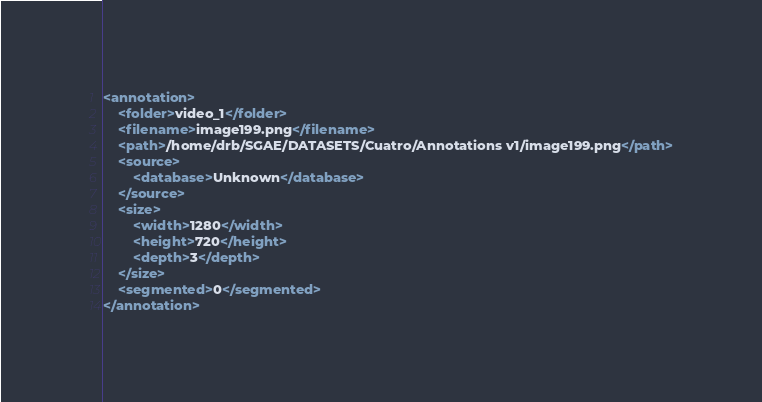<code> <loc_0><loc_0><loc_500><loc_500><_XML_><annotation>
	<folder>video_1</folder>
	<filename>image199.png</filename>
	<path>/home/drb/SGAE/DATASETS/Cuatro/Annotations v1/image199.png</path>
	<source>
		<database>Unknown</database>
	</source>
	<size>
		<width>1280</width>
		<height>720</height>
		<depth>3</depth>
	</size>
	<segmented>0</segmented>
</annotation></code> 